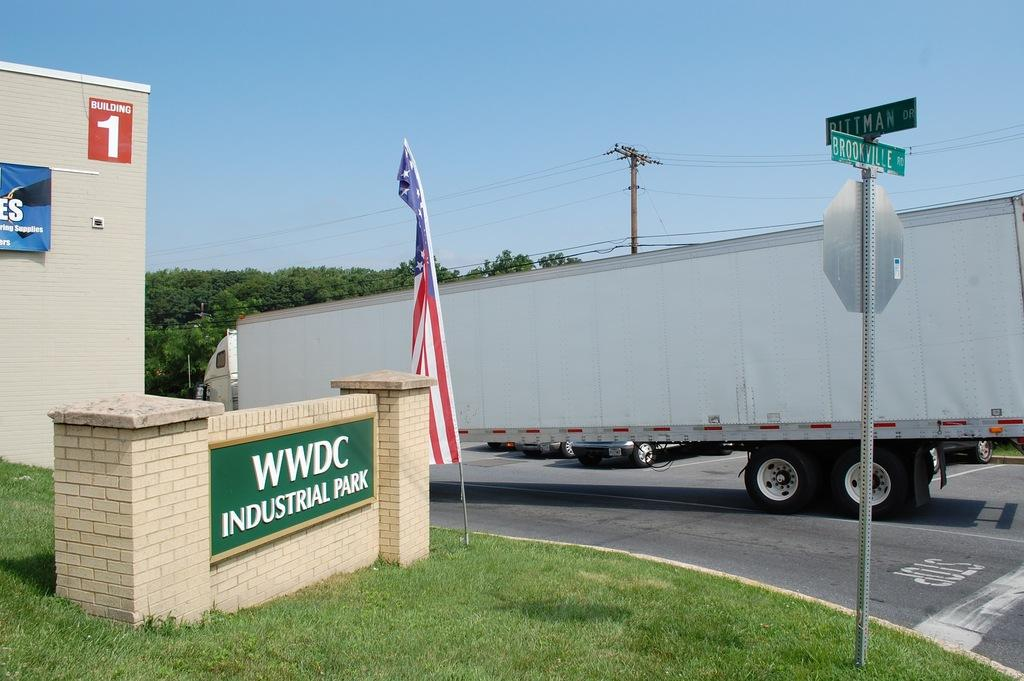What can be seen on the road in the image? There are motor vehicles on the road in the image. What structures are present in the image? Poles, name boards, sign boards, a flag, buildings, and trees are visible in the image. What type of infrastructure is present in the image? Electric poles and electric cables are present in the image. What part of the natural environment is visible in the image? Trees and the sky are visible in the image. What type of cushion is being used by the trees in the image? There are no cushions present in the image, as trees are natural elements and do not require cushions for support or comfort. 